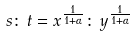<formula> <loc_0><loc_0><loc_500><loc_500>s \colon \, t = x ^ { \frac { 1 } { 1 + \alpha } } \colon \, y ^ { \frac { 1 } { 1 + \alpha } }</formula> 